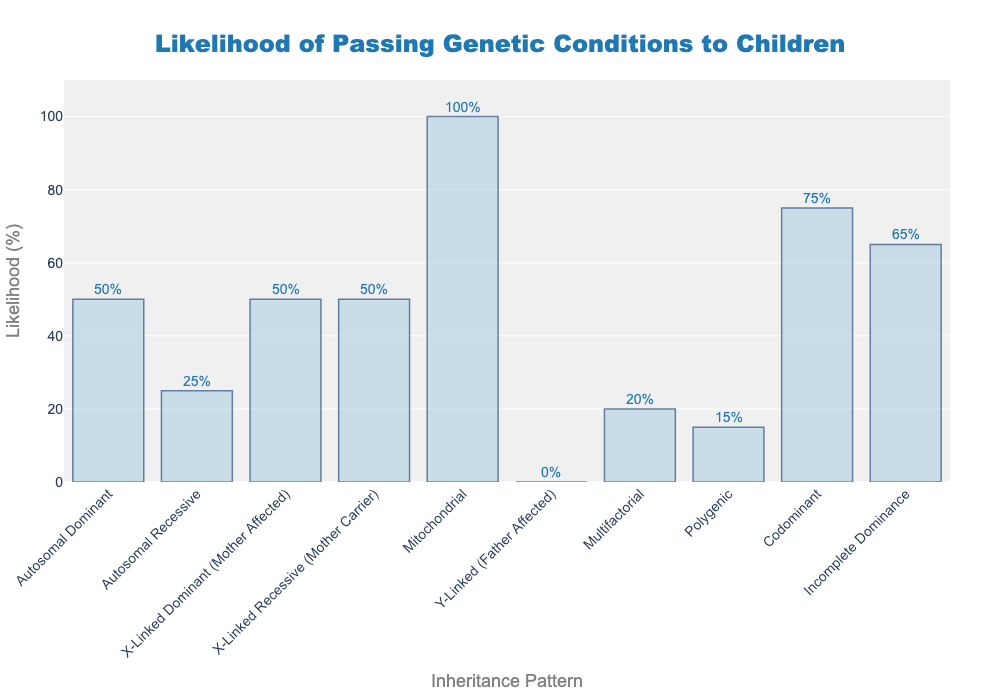What is the likelihood of passing a mitochondrial condition to a child? The bar chart shows that the likelihood of passing a mitochondrial condition is represented by the bar reaching up to 100% on the y-axis.
Answer: 100% Which type of inheritance pattern has a 50% chance of being passed to a child? The bars for "Autosomal Dominant," "X-Linked Dominant (Mother Affected)," and "X-Linked Recessive (Mother Carrier)" all reach up to the 50% mark on the y-axis.
Answer: Autosomal Dominant, X-Linked Dominant (Mother Affected), X-Linked Recessive (Mother Carrier) What is the difference in likelihood between passing a polygenic condition and a codominant condition? The likelihood of passing a polygenic condition is 15%, and for codominant, it is 75%. The difference is found by subtracting 15 from 75.
Answer: 60% Which condition has the lowest likelihood of being passed to a child? The bar chart shows that the "Y-Linked (Father Affected)" inheritance pattern is at 0% on the y-axis, meaning it has the lowest likelihood.
Answer: Y-Linked (Father Affected) How much higher is the likelihood of passing an incomplete dominance condition compared to a multifactorial condition? The likelihood of incomplete dominance is 65%, and multifactorial is 20%. To find the difference, subtract 20 from 65.
Answer: 45% Which inheritance pattern has a higher likelihood of passing to a child: autosomal recessive or polygenic? Check the heights of the bars: Autosomal Recessive is at 25% and Polygenic is at 15%.
Answer: Autosomal Recessive What is the combined likelihood of passing autosomal recessive and multifactorial conditions? The likelihood for autosomal recessive is 25%, and for multifactorial, it is 20%. The combined likelihood is found by adding these percentages.
Answer: 45% Which condition's likelihood is exactly halfway between autosomal dominant and polygenic? Autosomal Dominant is 50% and Polygenic is 15%. Halfway means the average, (50+15)/2 = 32.5%. The bar closest to this value is Autosomal Recessive at 25%.
Answer: Autosomal Recessive Compare the likelihood of autosomal dominant and incomplete dominance passing to a child. Which one has a higher likelihood and by how much? Autosomal Dominant is at 50% while Incomplete Dominance is at 65%. The difference is found by subtracting 50 from 65.
Answer: Incomplete Dominance by 15% What are the two inheritance patterns with the closest likelihoods of being passed to a child, and what is their likelihood difference? The closest likelihoods are Autosomal Dominant and X-Linked Dominant (Mother Affected), both at 50%. Their difference is 0 as they are equal.
Answer: Autosomal Dominant and X-Linked Dominant (Mother Affected), 0% 